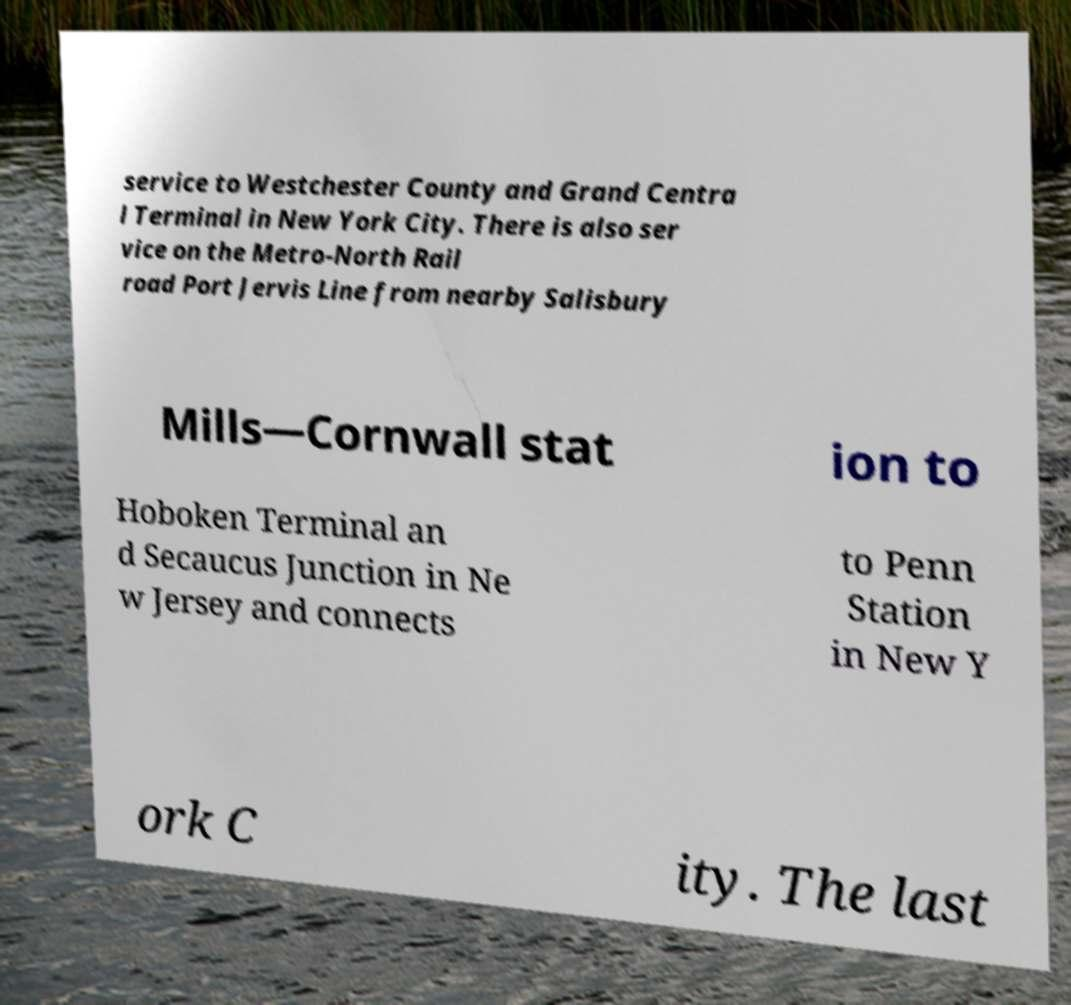There's text embedded in this image that I need extracted. Can you transcribe it verbatim? service to Westchester County and Grand Centra l Terminal in New York City. There is also ser vice on the Metro-North Rail road Port Jervis Line from nearby Salisbury Mills—Cornwall stat ion to Hoboken Terminal an d Secaucus Junction in Ne w Jersey and connects to Penn Station in New Y ork C ity. The last 